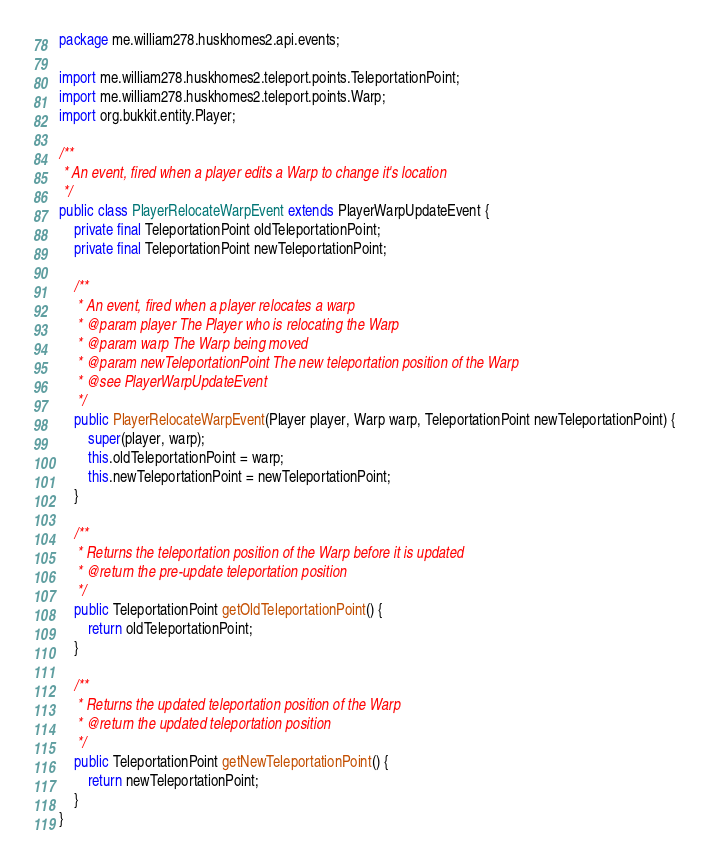<code> <loc_0><loc_0><loc_500><loc_500><_Java_>package me.william278.huskhomes2.api.events;

import me.william278.huskhomes2.teleport.points.TeleportationPoint;
import me.william278.huskhomes2.teleport.points.Warp;
import org.bukkit.entity.Player;

/**
 * An event, fired when a player edits a Warp to change it's location
 */
public class PlayerRelocateWarpEvent extends PlayerWarpUpdateEvent {
    private final TeleportationPoint oldTeleportationPoint;
    private final TeleportationPoint newTeleportationPoint;

    /**
     * An event, fired when a player relocates a warp
     * @param player The Player who is relocating the Warp
     * @param warp The Warp being moved
     * @param newTeleportationPoint The new teleportation position of the Warp
     * @see PlayerWarpUpdateEvent
     */
    public PlayerRelocateWarpEvent(Player player, Warp warp, TeleportationPoint newTeleportationPoint) {
        super(player, warp);
        this.oldTeleportationPoint = warp;
        this.newTeleportationPoint = newTeleportationPoint;
    }

    /**
     * Returns the teleportation position of the Warp before it is updated
     * @return the pre-update teleportation position
     */
    public TeleportationPoint getOldTeleportationPoint() {
        return oldTeleportationPoint;
    }

    /**
     * Returns the updated teleportation position of the Warp
     * @return the updated teleportation position
     */
    public TeleportationPoint getNewTeleportationPoint() {
        return newTeleportationPoint;
    }
}
</code> 